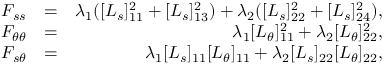Convert formula to latex. <formula><loc_0><loc_0><loc_500><loc_500>\begin{array} { r l r } { F _ { s s } } & { = } & { \lambda _ { 1 } ( [ L _ { s } ] _ { 1 1 } ^ { 2 } + [ L _ { s } ] _ { 1 3 } ^ { 2 } ) + \lambda _ { 2 } ( [ L _ { s } ] _ { 2 2 } ^ { 2 } + [ L _ { s } ] _ { 2 4 } ^ { 2 } ) , } \\ { F _ { \theta \theta } } & { = } & { \lambda _ { 1 } [ L _ { \theta } ] _ { 1 1 } ^ { 2 } + \lambda _ { 2 } [ L _ { \theta } ] _ { 2 2 } ^ { 2 } , } \\ { F _ { s \theta } } & { = } & { \lambda _ { 1 } [ L _ { s } ] _ { 1 1 } [ L _ { \theta } ] _ { 1 1 } + \lambda _ { 2 } [ L _ { s } ] _ { 2 2 } [ L _ { \theta } ] _ { 2 2 } , } \end{array}</formula> 